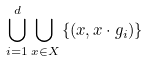Convert formula to latex. <formula><loc_0><loc_0><loc_500><loc_500>\bigcup _ { i = 1 } ^ { d } \bigcup _ { x \in X } \left \{ ( x , x \cdot g _ { i } ) \right \}</formula> 